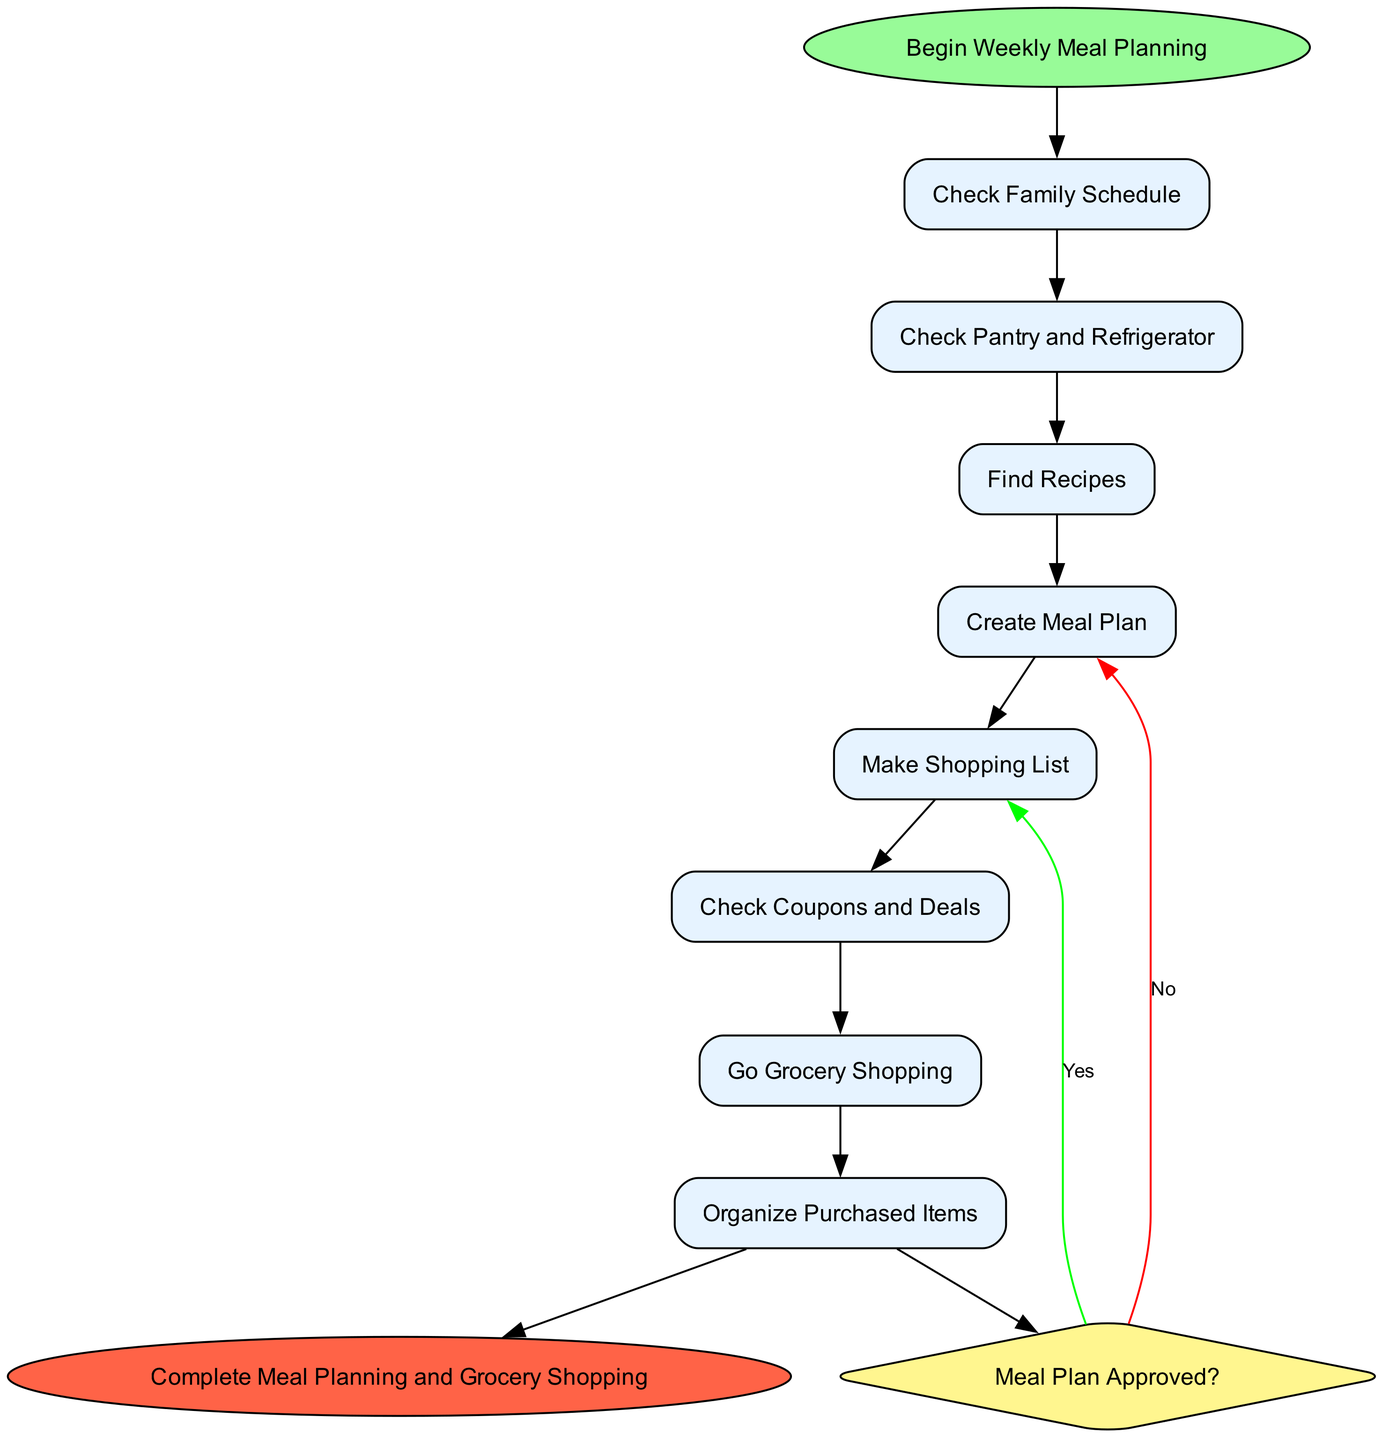What is the first activity in the diagram? The first activity is indicated immediately after the start node, which in this case is labeled as "Check Family Schedule".
Answer: Check Family Schedule How many activities are there in total? There are a total of eight activities listed in the diagram.
Answer: Eight What is the last activity before the decision point? By following the order of activities, the last activity before the decision is "Make Shopping List".
Answer: Make Shopping List What happens if the meal plan is not approved? If the meal plan is not approved, the flow will go back to "Find Recipes" to search for alternative meal options.
Answer: Find Recipes What is the outcome of the decision if the meal plan is approved? If the meal plan is approved, the process moves directly to the end node labeled "Complete Meal Planning and Grocery Shopping".
Answer: Complete Meal Planning and Grocery Shopping How many edges connect the activities? Counting all the connections between the activities, there are seven edges connecting the eight activities.
Answer: Seven What is the main purpose of the decision node? The decision node is there to assess whether the meal plan meets the family's needs and preferences.
Answer: To assess meal plan needs Describe the relationship between "Check Pantry and Refrigerator" and "Go Grocery Shopping". "Check Pantry and Refrigerator" is one of the preliminary activities that must be completed before proceeding to "Go Grocery Shopping", meaning it comes before it in the diagram.
Answer: Preliminary activity Which activity involves organizing purchased items? The activity that involves organizing purchased items is labeled as "Organize Purchased Items".
Answer: Organize Purchased Items 